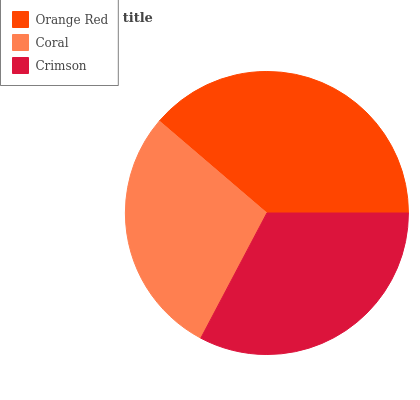Is Coral the minimum?
Answer yes or no. Yes. Is Orange Red the maximum?
Answer yes or no. Yes. Is Crimson the minimum?
Answer yes or no. No. Is Crimson the maximum?
Answer yes or no. No. Is Crimson greater than Coral?
Answer yes or no. Yes. Is Coral less than Crimson?
Answer yes or no. Yes. Is Coral greater than Crimson?
Answer yes or no. No. Is Crimson less than Coral?
Answer yes or no. No. Is Crimson the high median?
Answer yes or no. Yes. Is Crimson the low median?
Answer yes or no. Yes. Is Orange Red the high median?
Answer yes or no. No. Is Coral the low median?
Answer yes or no. No. 